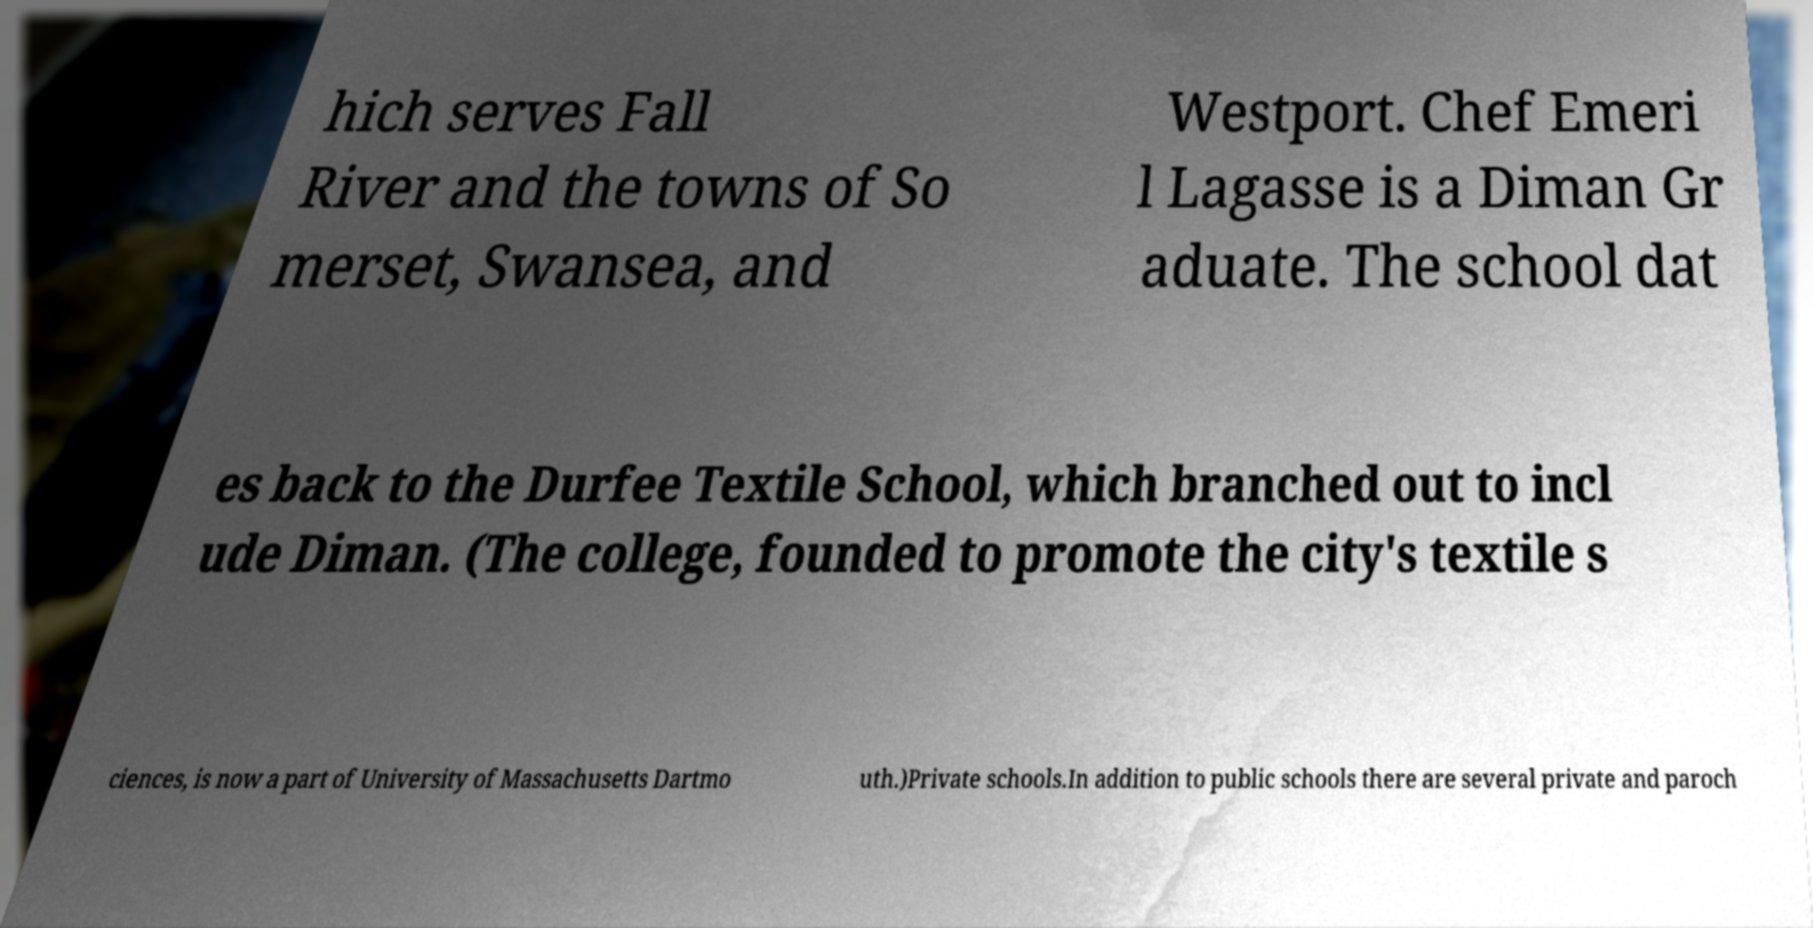Could you assist in decoding the text presented in this image and type it out clearly? hich serves Fall River and the towns of So merset, Swansea, and Westport. Chef Emeri l Lagasse is a Diman Gr aduate. The school dat es back to the Durfee Textile School, which branched out to incl ude Diman. (The college, founded to promote the city's textile s ciences, is now a part of University of Massachusetts Dartmo uth.)Private schools.In addition to public schools there are several private and paroch 